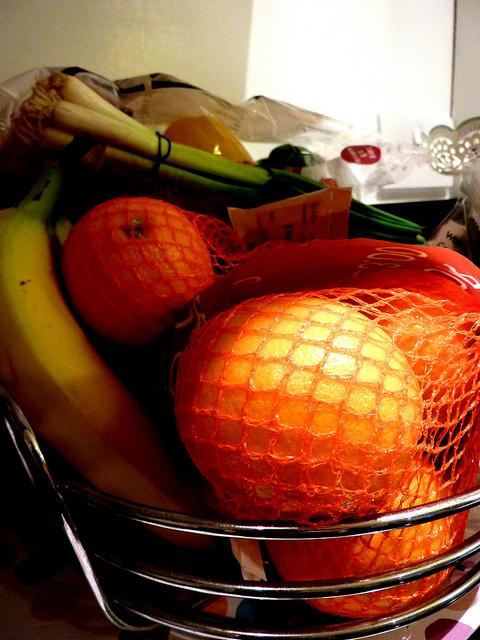What vegetable is bundled together? Please explain your reasoning. onion. There is a rubber band around the green vegetables. 